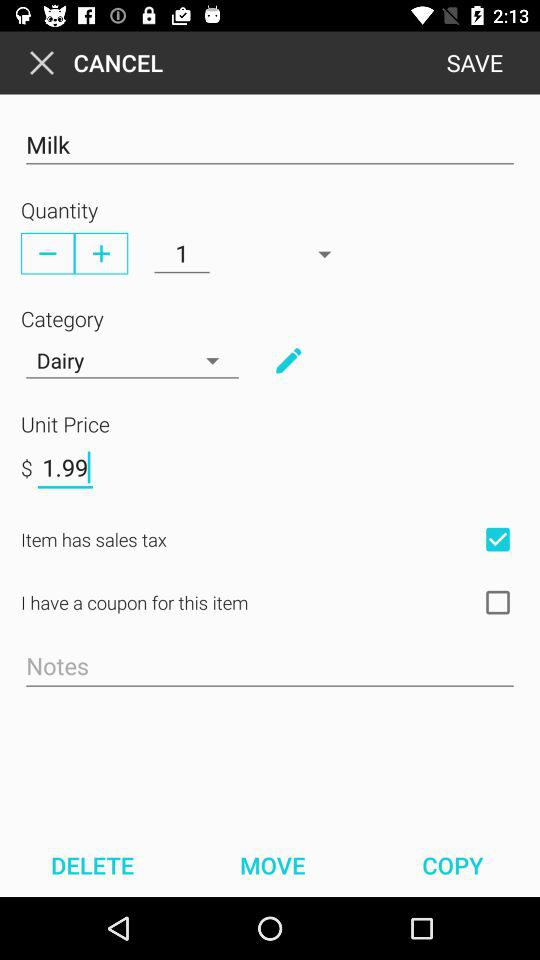How much is the quantity? The quantity is 1. 